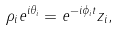Convert formula to latex. <formula><loc_0><loc_0><loc_500><loc_500>\rho _ { i } e ^ { i \theta _ { i } } = e ^ { - i \phi _ { i } t } z _ { i } ,</formula> 